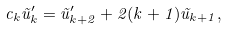Convert formula to latex. <formula><loc_0><loc_0><loc_500><loc_500>c _ { k } \tilde { u } ^ { \prime } _ { k } = \tilde { u } ^ { \prime } _ { k + 2 } + 2 ( k + 1 ) \tilde { u } _ { k + 1 } ,</formula> 